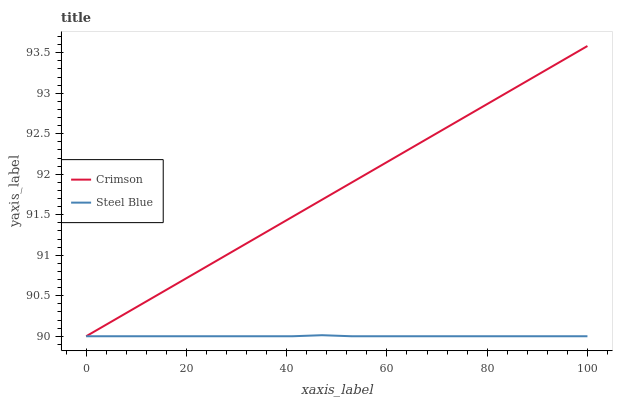Does Steel Blue have the minimum area under the curve?
Answer yes or no. Yes. Does Crimson have the maximum area under the curve?
Answer yes or no. Yes. Does Steel Blue have the maximum area under the curve?
Answer yes or no. No. Is Crimson the smoothest?
Answer yes or no. Yes. Is Steel Blue the roughest?
Answer yes or no. Yes. Is Steel Blue the smoothest?
Answer yes or no. No. Does Crimson have the lowest value?
Answer yes or no. Yes. Does Crimson have the highest value?
Answer yes or no. Yes. Does Steel Blue have the highest value?
Answer yes or no. No. Does Steel Blue intersect Crimson?
Answer yes or no. Yes. Is Steel Blue less than Crimson?
Answer yes or no. No. Is Steel Blue greater than Crimson?
Answer yes or no. No. 